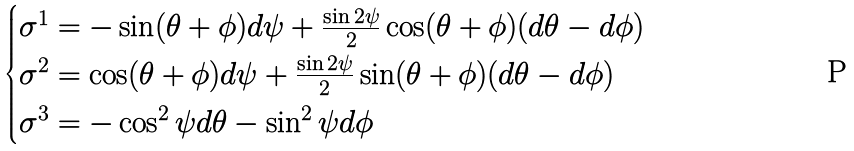<formula> <loc_0><loc_0><loc_500><loc_500>\begin{cases} \sigma ^ { 1 } = - \sin ( \theta + \phi ) d \psi + \frac { \sin 2 \psi } { 2 } \cos ( \theta + \phi ) ( d \theta - d \phi ) \\ \sigma ^ { 2 } = \cos ( \theta + \phi ) d \psi + \frac { \sin 2 \psi } { 2 } \sin ( \theta + \phi ) ( d \theta - d \phi ) \\ \sigma ^ { 3 } = - \cos ^ { 2 } \psi d \theta - \sin ^ { 2 } \psi d \phi \end{cases}</formula> 